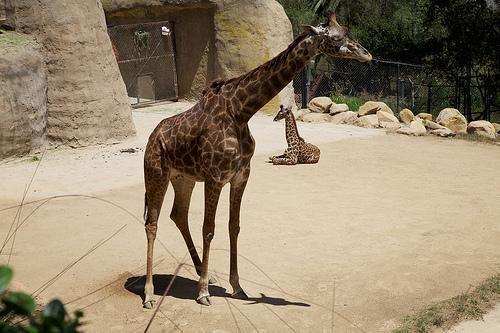How many giraffee is sitting on the floor?
Give a very brief answer. 1. How many giraffes are standing up?
Give a very brief answer. 1. 